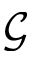<formula> <loc_0><loc_0><loc_500><loc_500>\mathcal { G }</formula> 